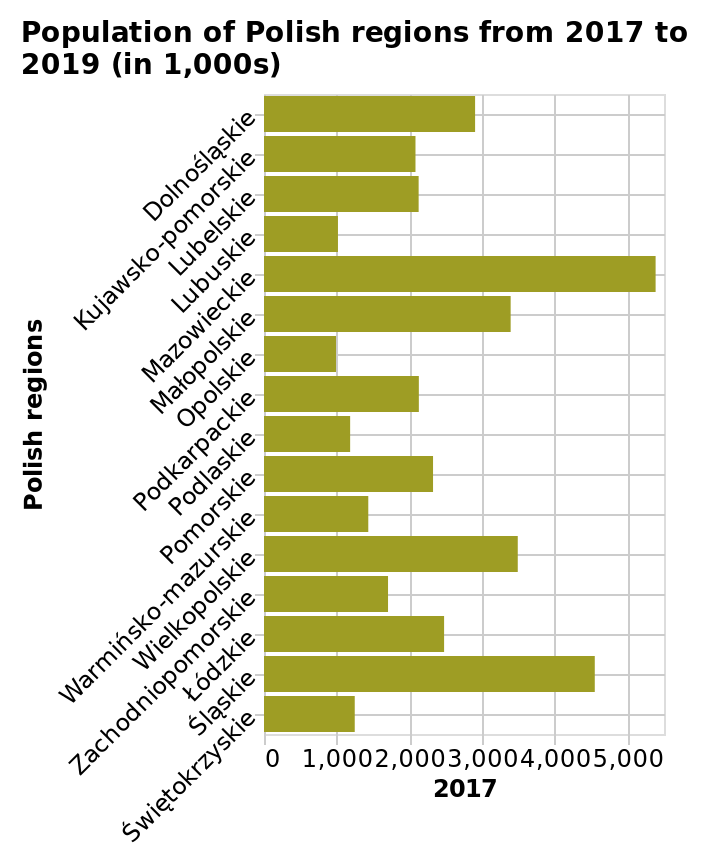<image>
What is the scale of the x-axis in the bar plot? The scale of the x-axis in the bar plot is linear from 0 to 5,000. 